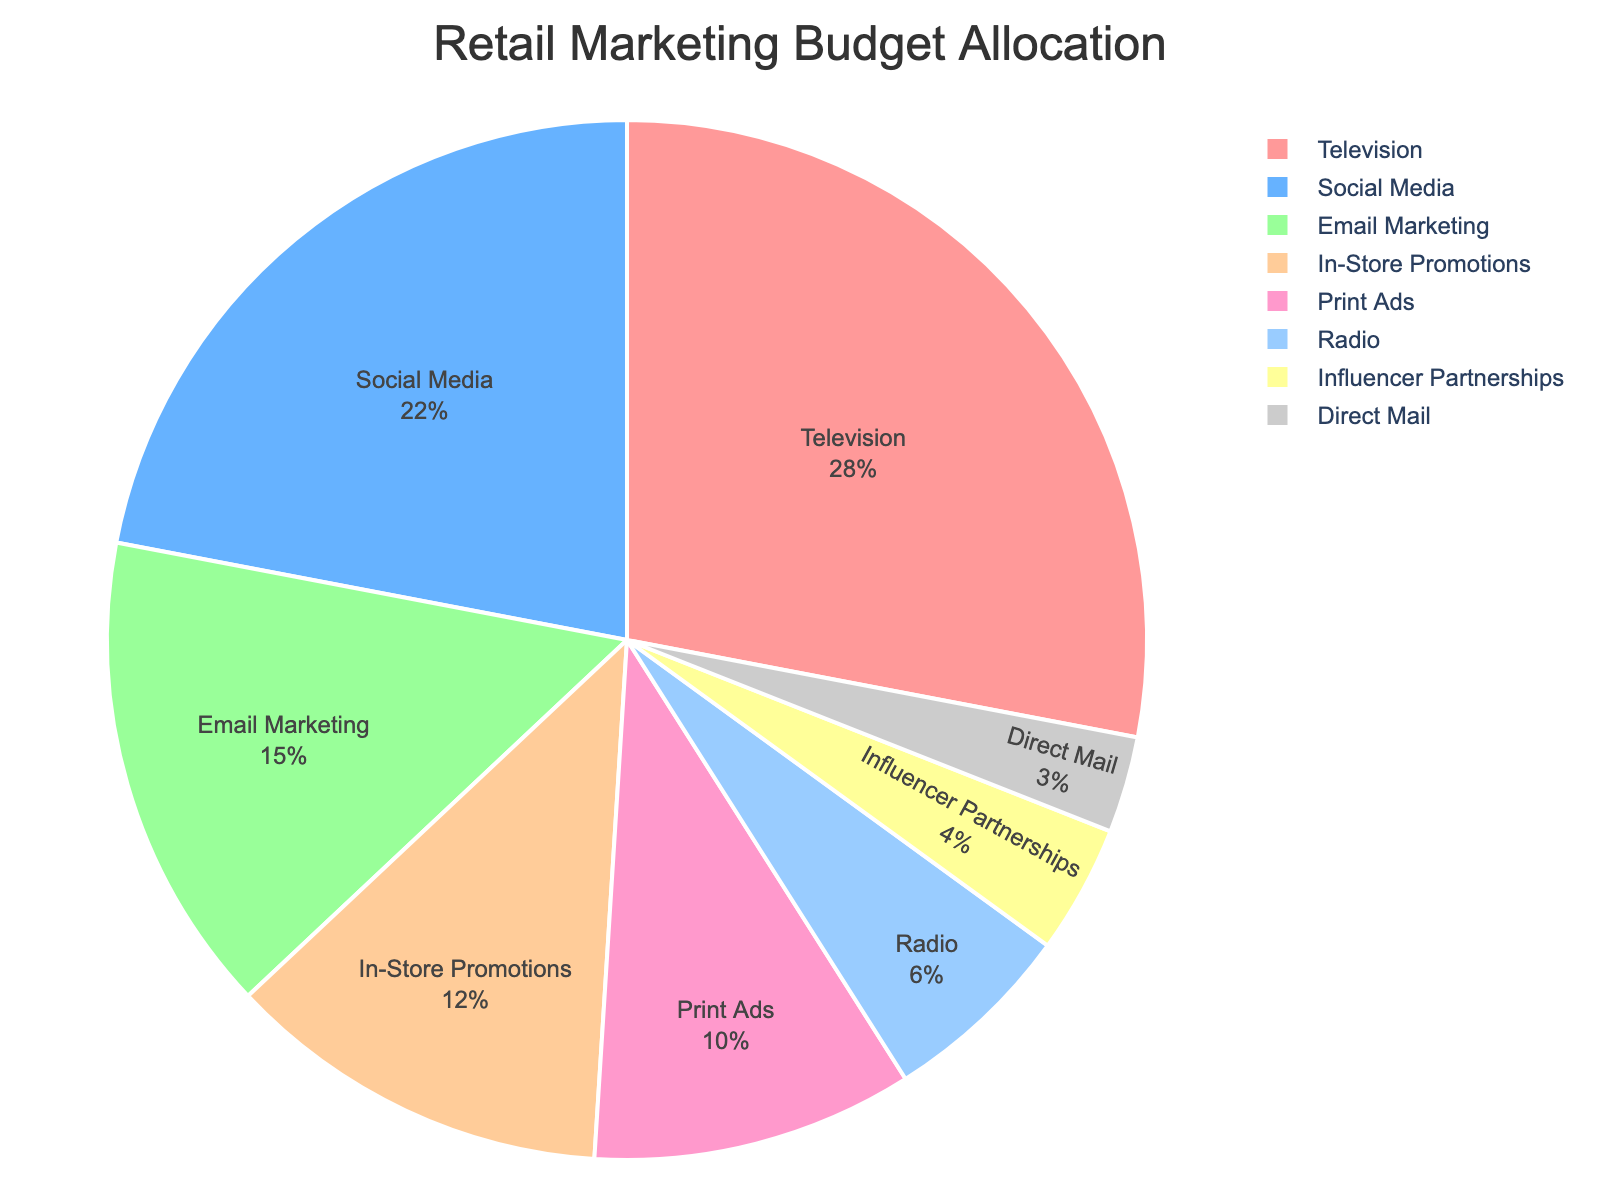What percentage of the budget is allocated to Social Media? The section labeled "Social Media" shows a percentage value within the pie chart. It can be directly read.
Answer: 22% Which advertising channel receives the smallest portion of the budget? Look for the smallest slice in the pie chart, which represents the smallest percentage.
Answer: Direct Mail Is the budget allocated to Television greater than the combined budget for Radio and Print Ads? Identify the percentage for Television, Radio, and Print Ads. Then compare Television's percentage (28%) with the sum of Radio (6%) and Print Ads (10%), which is 28% vs 16%.
Answer: Yes How much more budget is allocated to In-Store Promotions than to Influencer Partnerships? Locate the percentages for both In-Store Promotions (12%) and Influencer Partnerships (4%). Subtract the smaller from the larger: 12% - 4%.
Answer: 8% What is the combined percentage for Television, Social Media, and Email Marketing? Add the percentages of Television (28%), Social Media (22%), and Email Marketing (15%). 28% + 22% + 15%.
Answer: 65% Which channel has a higher budget, In-Store Promotions or Print Ads? Compare the slices labeled "In-Store Promotions" and "Print Ads". In-Store Promotions is 12%, Print Ads is 10%.
Answer: In-Store Promotions What percentage of the budget is allocated to channels other than Television? Subtract the Television percentage (28%) from 100%. Calculate: 100% - 28%.
Answer: 72% What is the difference between the budget allocated to Email Marketing and Social Media? Find the percentages for Email Marketing (15%) and Social Media (22%). Subtract the smaller from the larger: 22% - 15%.
Answer: 7% Is the budget for In-Store Promotions closer to Radio's budget or Email Marketing's budget? Determine the absolute differences: In-Store Promotions (12%) minus Radio (6%) is 6%; In-Store Promotions minus Email Marketing (15%) is 3%. Compare the two differences.
Answer: Email Marketing What percentage of the budget is allocated to channels with less than 10% each? Identify the channels under 10%: Radio (6%), Influencer Partnerships (4%), and Direct Mail (3%). Add these percentages together: 6% + 4% + 3%.
Answer: 13% 